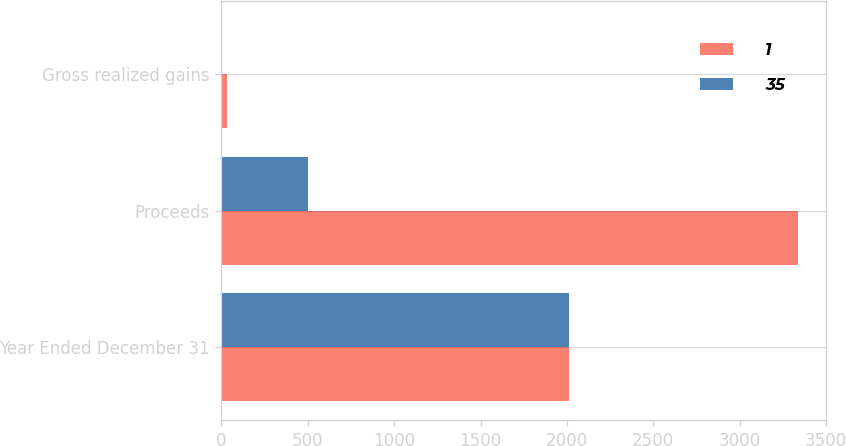Convert chart to OTSL. <chart><loc_0><loc_0><loc_500><loc_500><stacked_bar_chart><ecel><fcel>Year Ended December 31<fcel>Proceeds<fcel>Gross realized gains<nl><fcel>1<fcel>2012<fcel>3336<fcel>35<nl><fcel>35<fcel>2011<fcel>500<fcel>1<nl></chart> 